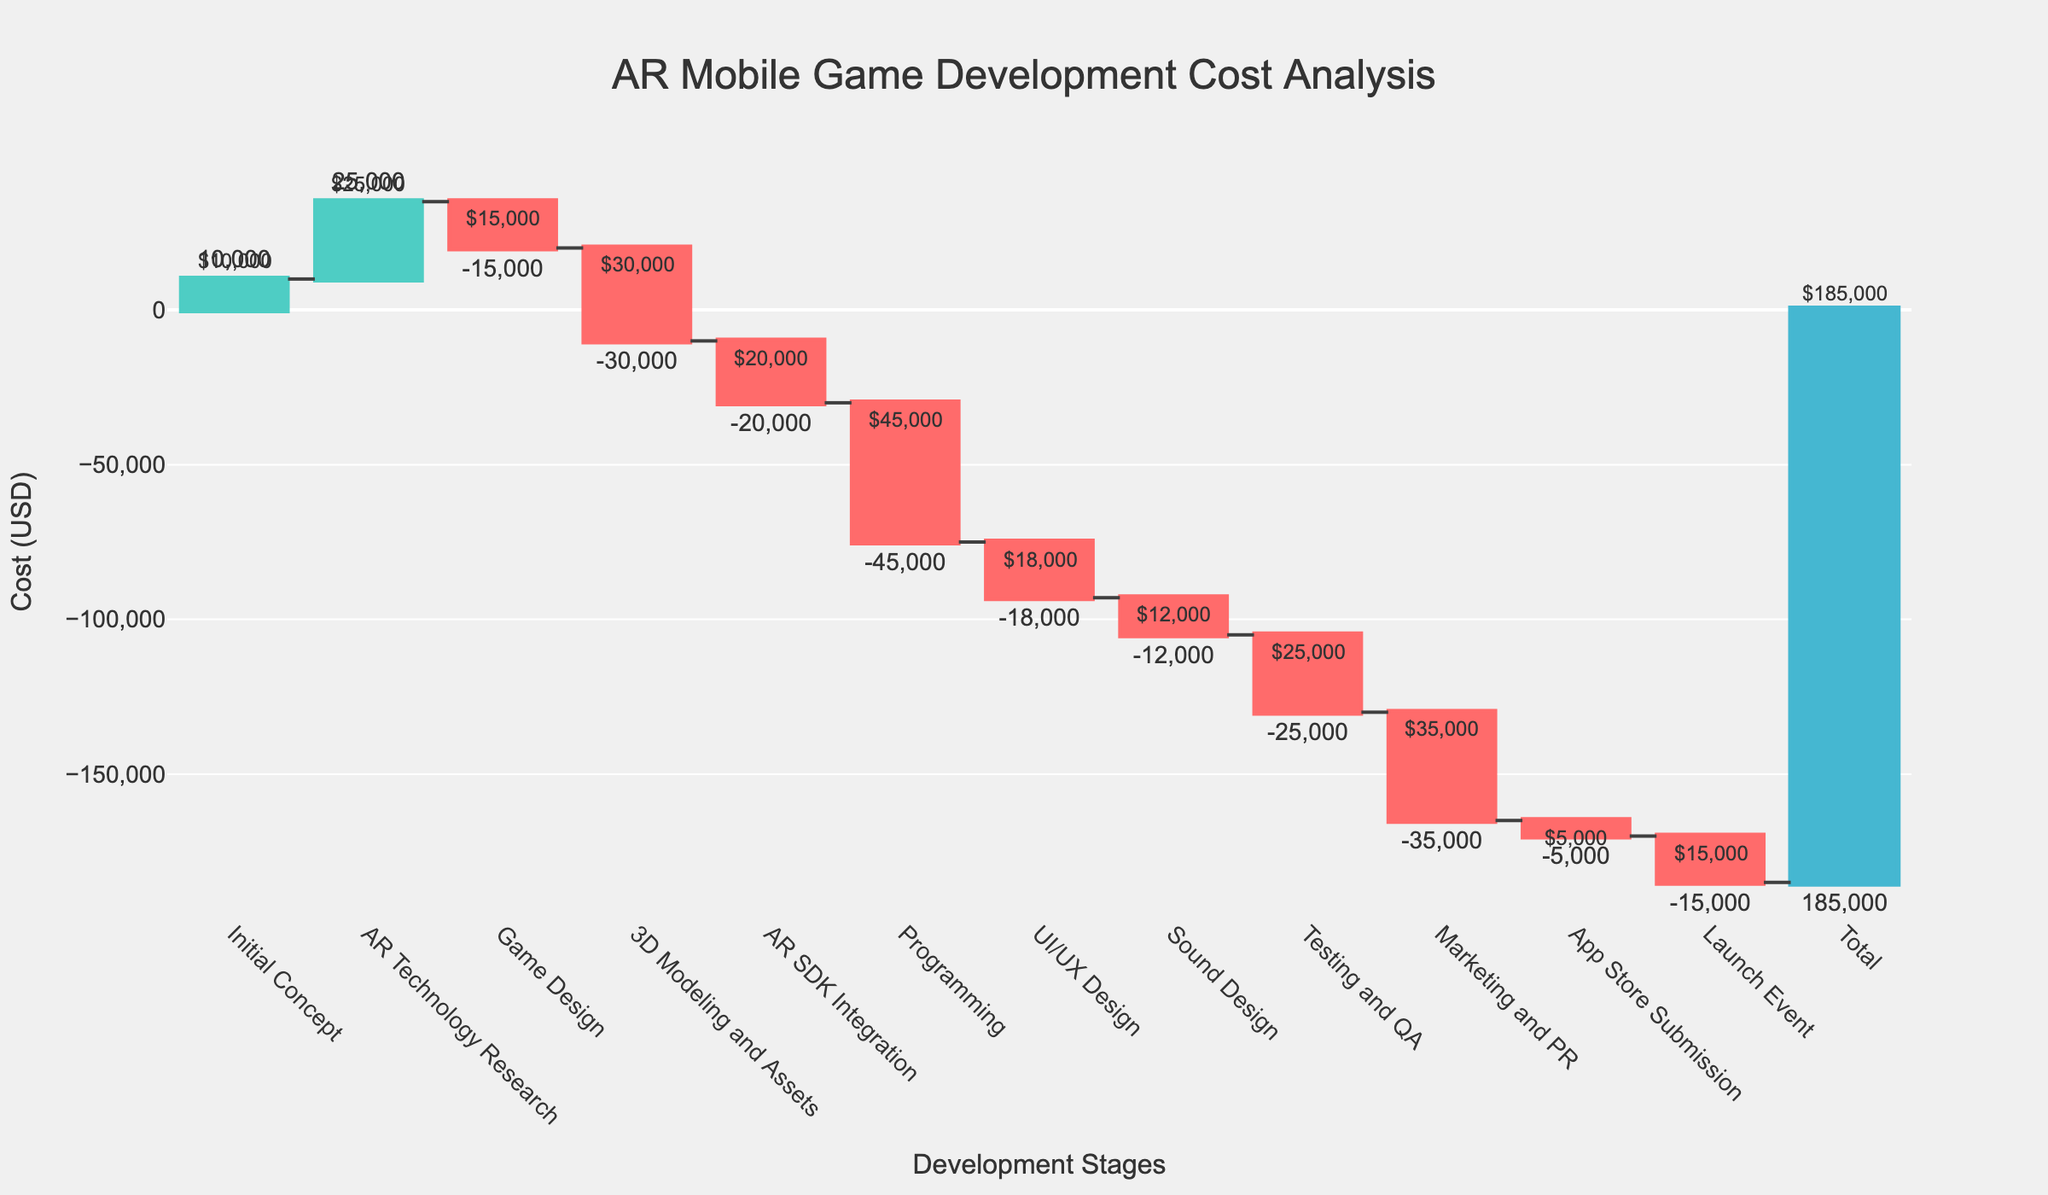What is the title of the waterfall chart? The title of the chart is usually located at the top and is often bolded to stand out. In this case, it reads as "AR Mobile Game Development Cost Analysis."
Answer: AR Mobile Game Development Cost Analysis Which development stage has the highest cost? By analyzing the bar heights and labels, the "Programming" stage shows the largest decrease, indicating the highest cost.
Answer: Programming What is the final cumulative cost at the end of the project? The final cumulative cost is represented by the last bar labeled "Total," which stands out due to its different color. The label shows $185,000.
Answer: $185,000 How much was spent on the "Marketing and PR" stage? The label on the bar for "Marketing and PR" indicates -$35,000, as it is a downward bar.
Answer: -$35,000 What is the difference in costs between "Programming" and "Testing and QA"? The bar for "Programming" shows -$45,000 and "Testing and QA" shows -$25,000. The difference is calculated as $45,000 - $25,000 = $20,000.
Answer: $20,000 Which stages contributed positively to the cumulative cost? Bars that point upwards contribute positively. Analyzing the chart, "Initial Concept," "AR Technology Research," and "Total" stages have positive values.
Answer: Initial Concept, AR Technology Research, Total How much was the cost for the "AR SDK Integration" stage? The "AR SDK Integration" stage in the chart shows a downward bar labeled -$20,000.
Answer: -$20,000 Which stage incurred the least cost and what was it? By examining the heights and values of the downward bars, "App Store Submission" is the smallest, showing -$5,000.
Answer: App Store Submission, -$5,000 What is the total spending up to the "Sound Design" stage? Sum the values up to "Sound Design": $10,000 (Initial Concept) + $25,000 (AR Technology Research) - $15,000 (Game Design) - $30,000 (3D Modeling and Assets) - $20,000 (AR SDK Integration) - $45,000 (Programming) - $18,000 (UI/UX Design) - $12,000 (Sound Design) = -$105,000.
Answer: -$105,000 Which two stages had close costs and differed by only $3,000? By checking neighboring values, "UI/UX Design" (-$18,000) and "Sound Design" (-$12,000) have a difference of $18,000 - $12,000 = $6,000; however, "Testing and QA" (-$25,000) and "AR SDK Integration" (-$20,000) differ by $5,000. None differ by exactly $3,000.
Answer: None 